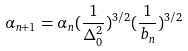<formula> <loc_0><loc_0><loc_500><loc_500>\alpha _ { n + 1 } = \alpha _ { n } ( \frac { 1 } { \Delta _ { 0 } ^ { 2 } } ) ^ { 3 / 2 } ( \frac { 1 } { b _ { n } } ) ^ { 3 / 2 }</formula> 